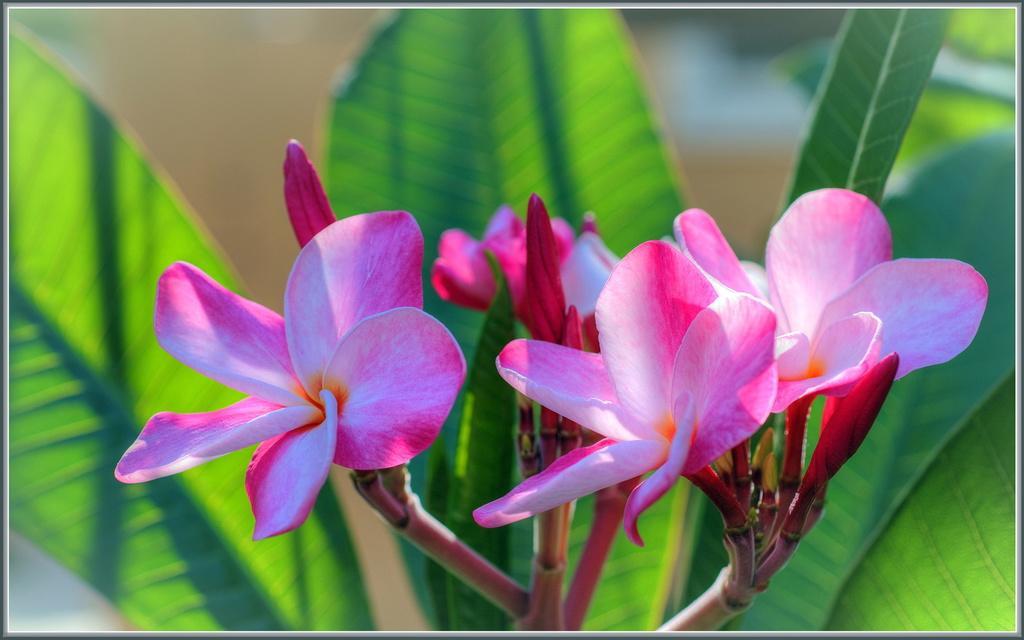How would you summarize this image in a sentence or two? In this picture we can see flowers and in the background we can see leaves. 